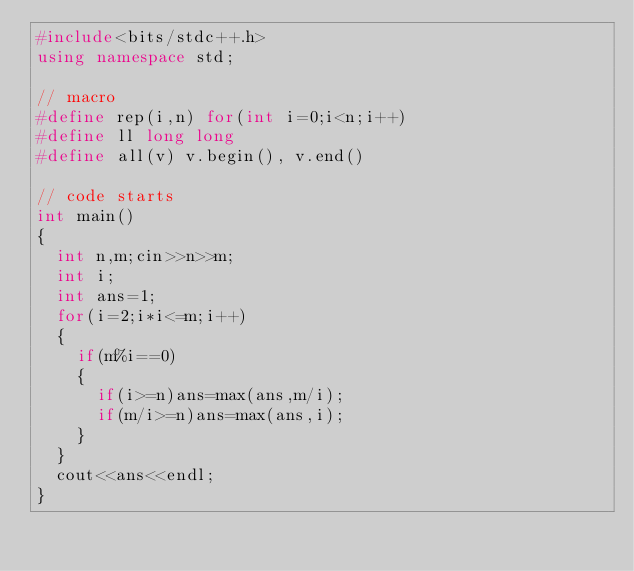Convert code to text. <code><loc_0><loc_0><loc_500><loc_500><_C++_>#include<bits/stdc++.h>
using namespace std;

// macro
#define rep(i,n) for(int i=0;i<n;i++)
#define ll long long
#define all(v) v.begin(), v.end()

// code starts
int main()
{
  int n,m;cin>>n>>m;
  int i;
  int ans=1;
  for(i=2;i*i<=m;i++)
  {
    if(m%i==0)
    {
      if(i>=n)ans=max(ans,m/i);
      if(m/i>=n)ans=max(ans,i);
    }
  }
  cout<<ans<<endl;
}
</code> 